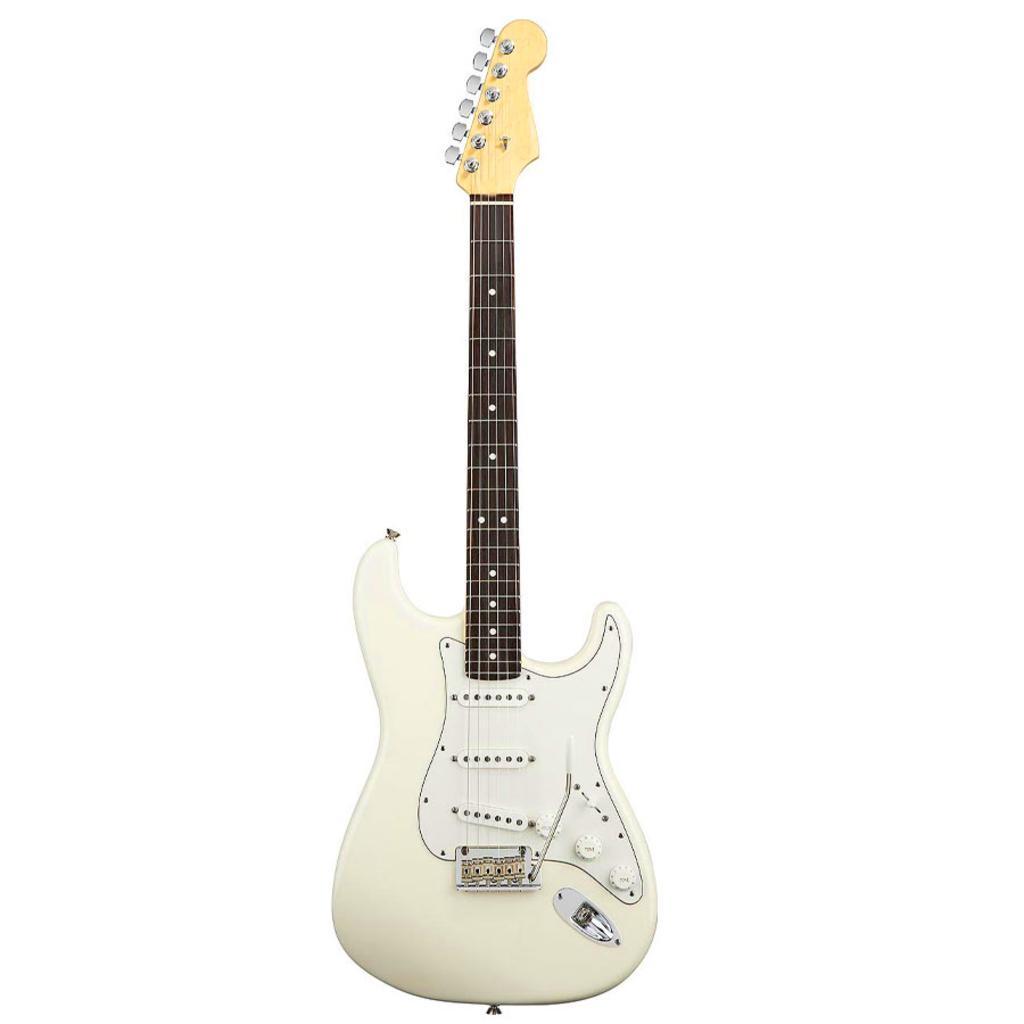In one or two sentences, can you explain what this image depicts? In this image there is a white guitar. 